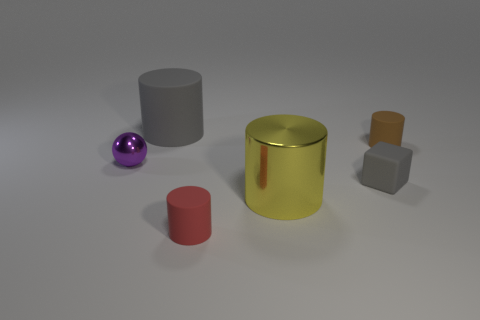I see various objects. Could you describe the material or texture of any of them? Certainly. The purple sphere appears to have a reflective, glossy surface, likely suggesting a polished metal or plastic. The gray cylinder seems to be made of rubber due to its matte finish. The gold cylinder has a shiny, metallic surface which reflects light well, indicating a metal material. The red cylinder looks like it could be made of a matte painted material, possibly wood or hard plastic. The small orange cube has a slight sheen which suggests a plastic material. 